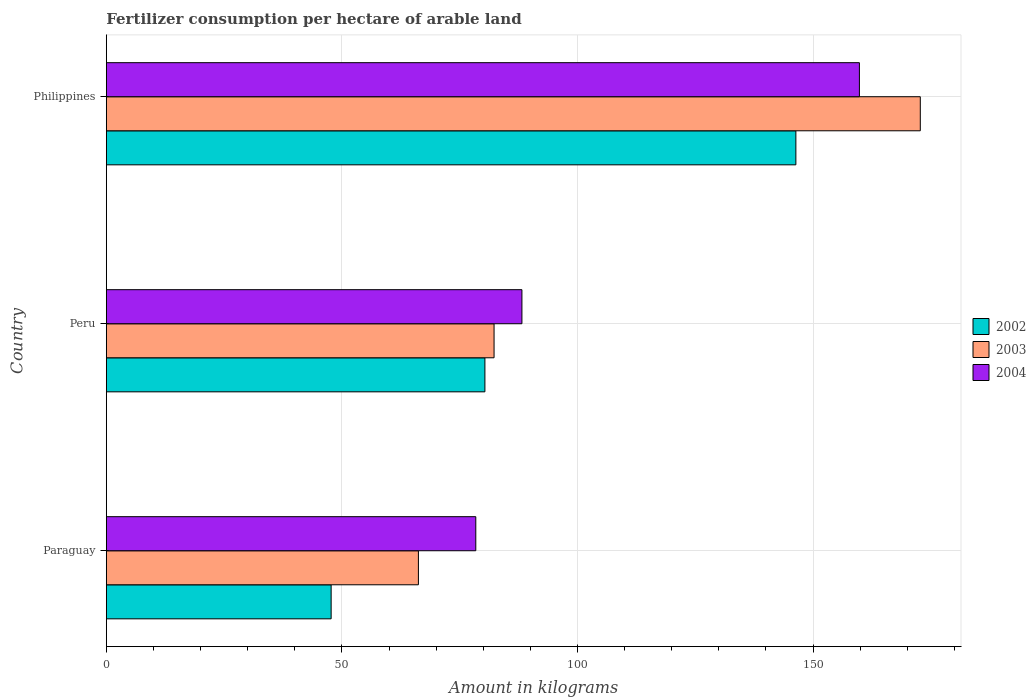How many different coloured bars are there?
Make the answer very short. 3. How many groups of bars are there?
Provide a succinct answer. 3. Are the number of bars per tick equal to the number of legend labels?
Offer a very short reply. Yes. Are the number of bars on each tick of the Y-axis equal?
Your answer should be very brief. Yes. How many bars are there on the 3rd tick from the top?
Offer a terse response. 3. How many bars are there on the 2nd tick from the bottom?
Give a very brief answer. 3. What is the label of the 3rd group of bars from the top?
Make the answer very short. Paraguay. What is the amount of fertilizer consumption in 2002 in Peru?
Ensure brevity in your answer.  80.35. Across all countries, what is the maximum amount of fertilizer consumption in 2002?
Provide a short and direct response. 146.36. Across all countries, what is the minimum amount of fertilizer consumption in 2003?
Make the answer very short. 66.24. In which country was the amount of fertilizer consumption in 2003 minimum?
Give a very brief answer. Paraguay. What is the total amount of fertilizer consumption in 2002 in the graph?
Your answer should be very brief. 274.43. What is the difference between the amount of fertilizer consumption in 2004 in Peru and that in Philippines?
Make the answer very short. -71.63. What is the difference between the amount of fertilizer consumption in 2003 in Peru and the amount of fertilizer consumption in 2002 in Philippines?
Give a very brief answer. -64.06. What is the average amount of fertilizer consumption in 2002 per country?
Offer a very short reply. 91.48. What is the difference between the amount of fertilizer consumption in 2004 and amount of fertilizer consumption in 2003 in Paraguay?
Ensure brevity in your answer.  12.18. What is the ratio of the amount of fertilizer consumption in 2004 in Paraguay to that in Philippines?
Your answer should be very brief. 0.49. Is the amount of fertilizer consumption in 2003 in Paraguay less than that in Philippines?
Your response must be concise. Yes. What is the difference between the highest and the second highest amount of fertilizer consumption in 2004?
Offer a terse response. 71.63. What is the difference between the highest and the lowest amount of fertilizer consumption in 2004?
Offer a terse response. 81.42. In how many countries, is the amount of fertilizer consumption in 2003 greater than the average amount of fertilizer consumption in 2003 taken over all countries?
Offer a very short reply. 1. What does the 1st bar from the top in Philippines represents?
Your answer should be very brief. 2004. Are the values on the major ticks of X-axis written in scientific E-notation?
Provide a short and direct response. No. Where does the legend appear in the graph?
Make the answer very short. Center right. What is the title of the graph?
Provide a short and direct response. Fertilizer consumption per hectare of arable land. What is the label or title of the X-axis?
Keep it short and to the point. Amount in kilograms. What is the Amount in kilograms in 2002 in Paraguay?
Your answer should be compact. 47.72. What is the Amount in kilograms in 2003 in Paraguay?
Give a very brief answer. 66.24. What is the Amount in kilograms in 2004 in Paraguay?
Your response must be concise. 78.42. What is the Amount in kilograms in 2002 in Peru?
Offer a terse response. 80.35. What is the Amount in kilograms of 2003 in Peru?
Your response must be concise. 82.3. What is the Amount in kilograms in 2004 in Peru?
Offer a very short reply. 88.21. What is the Amount in kilograms of 2002 in Philippines?
Your answer should be very brief. 146.36. What is the Amount in kilograms in 2003 in Philippines?
Your response must be concise. 172.77. What is the Amount in kilograms of 2004 in Philippines?
Keep it short and to the point. 159.85. Across all countries, what is the maximum Amount in kilograms in 2002?
Give a very brief answer. 146.36. Across all countries, what is the maximum Amount in kilograms in 2003?
Make the answer very short. 172.77. Across all countries, what is the maximum Amount in kilograms of 2004?
Your answer should be compact. 159.85. Across all countries, what is the minimum Amount in kilograms of 2002?
Give a very brief answer. 47.72. Across all countries, what is the minimum Amount in kilograms in 2003?
Keep it short and to the point. 66.24. Across all countries, what is the minimum Amount in kilograms in 2004?
Provide a short and direct response. 78.42. What is the total Amount in kilograms in 2002 in the graph?
Your answer should be compact. 274.43. What is the total Amount in kilograms of 2003 in the graph?
Ensure brevity in your answer.  321.31. What is the total Amount in kilograms of 2004 in the graph?
Keep it short and to the point. 326.48. What is the difference between the Amount in kilograms in 2002 in Paraguay and that in Peru?
Offer a terse response. -32.64. What is the difference between the Amount in kilograms in 2003 in Paraguay and that in Peru?
Make the answer very short. -16.06. What is the difference between the Amount in kilograms of 2004 in Paraguay and that in Peru?
Offer a terse response. -9.79. What is the difference between the Amount in kilograms of 2002 in Paraguay and that in Philippines?
Your answer should be compact. -98.65. What is the difference between the Amount in kilograms of 2003 in Paraguay and that in Philippines?
Provide a short and direct response. -106.53. What is the difference between the Amount in kilograms in 2004 in Paraguay and that in Philippines?
Make the answer very short. -81.42. What is the difference between the Amount in kilograms in 2002 in Peru and that in Philippines?
Make the answer very short. -66.01. What is the difference between the Amount in kilograms in 2003 in Peru and that in Philippines?
Offer a very short reply. -90.47. What is the difference between the Amount in kilograms in 2004 in Peru and that in Philippines?
Keep it short and to the point. -71.63. What is the difference between the Amount in kilograms of 2002 in Paraguay and the Amount in kilograms of 2003 in Peru?
Your answer should be compact. -34.58. What is the difference between the Amount in kilograms in 2002 in Paraguay and the Amount in kilograms in 2004 in Peru?
Make the answer very short. -40.5. What is the difference between the Amount in kilograms of 2003 in Paraguay and the Amount in kilograms of 2004 in Peru?
Ensure brevity in your answer.  -21.97. What is the difference between the Amount in kilograms of 2002 in Paraguay and the Amount in kilograms of 2003 in Philippines?
Ensure brevity in your answer.  -125.05. What is the difference between the Amount in kilograms of 2002 in Paraguay and the Amount in kilograms of 2004 in Philippines?
Provide a succinct answer. -112.13. What is the difference between the Amount in kilograms of 2003 in Paraguay and the Amount in kilograms of 2004 in Philippines?
Offer a terse response. -93.61. What is the difference between the Amount in kilograms in 2002 in Peru and the Amount in kilograms in 2003 in Philippines?
Ensure brevity in your answer.  -92.41. What is the difference between the Amount in kilograms in 2002 in Peru and the Amount in kilograms in 2004 in Philippines?
Offer a very short reply. -79.49. What is the difference between the Amount in kilograms of 2003 in Peru and the Amount in kilograms of 2004 in Philippines?
Make the answer very short. -77.55. What is the average Amount in kilograms of 2002 per country?
Your answer should be very brief. 91.48. What is the average Amount in kilograms of 2003 per country?
Offer a terse response. 107.1. What is the average Amount in kilograms of 2004 per country?
Provide a short and direct response. 108.83. What is the difference between the Amount in kilograms in 2002 and Amount in kilograms in 2003 in Paraguay?
Provide a short and direct response. -18.52. What is the difference between the Amount in kilograms in 2002 and Amount in kilograms in 2004 in Paraguay?
Your answer should be compact. -30.71. What is the difference between the Amount in kilograms in 2003 and Amount in kilograms in 2004 in Paraguay?
Ensure brevity in your answer.  -12.18. What is the difference between the Amount in kilograms of 2002 and Amount in kilograms of 2003 in Peru?
Give a very brief answer. -1.94. What is the difference between the Amount in kilograms in 2002 and Amount in kilograms in 2004 in Peru?
Make the answer very short. -7.86. What is the difference between the Amount in kilograms in 2003 and Amount in kilograms in 2004 in Peru?
Your response must be concise. -5.91. What is the difference between the Amount in kilograms of 2002 and Amount in kilograms of 2003 in Philippines?
Your answer should be compact. -26.41. What is the difference between the Amount in kilograms of 2002 and Amount in kilograms of 2004 in Philippines?
Offer a terse response. -13.48. What is the difference between the Amount in kilograms of 2003 and Amount in kilograms of 2004 in Philippines?
Provide a succinct answer. 12.92. What is the ratio of the Amount in kilograms in 2002 in Paraguay to that in Peru?
Keep it short and to the point. 0.59. What is the ratio of the Amount in kilograms in 2003 in Paraguay to that in Peru?
Your response must be concise. 0.8. What is the ratio of the Amount in kilograms in 2004 in Paraguay to that in Peru?
Ensure brevity in your answer.  0.89. What is the ratio of the Amount in kilograms of 2002 in Paraguay to that in Philippines?
Keep it short and to the point. 0.33. What is the ratio of the Amount in kilograms of 2003 in Paraguay to that in Philippines?
Your answer should be very brief. 0.38. What is the ratio of the Amount in kilograms in 2004 in Paraguay to that in Philippines?
Keep it short and to the point. 0.49. What is the ratio of the Amount in kilograms in 2002 in Peru to that in Philippines?
Your response must be concise. 0.55. What is the ratio of the Amount in kilograms of 2003 in Peru to that in Philippines?
Provide a short and direct response. 0.48. What is the ratio of the Amount in kilograms in 2004 in Peru to that in Philippines?
Your response must be concise. 0.55. What is the difference between the highest and the second highest Amount in kilograms of 2002?
Make the answer very short. 66.01. What is the difference between the highest and the second highest Amount in kilograms of 2003?
Keep it short and to the point. 90.47. What is the difference between the highest and the second highest Amount in kilograms of 2004?
Ensure brevity in your answer.  71.63. What is the difference between the highest and the lowest Amount in kilograms in 2002?
Your response must be concise. 98.65. What is the difference between the highest and the lowest Amount in kilograms in 2003?
Your response must be concise. 106.53. What is the difference between the highest and the lowest Amount in kilograms in 2004?
Make the answer very short. 81.42. 